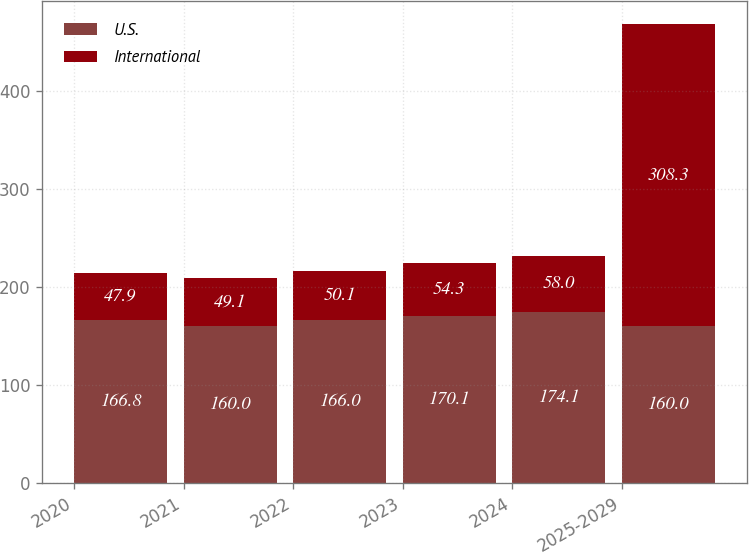Convert chart to OTSL. <chart><loc_0><loc_0><loc_500><loc_500><stacked_bar_chart><ecel><fcel>2020<fcel>2021<fcel>2022<fcel>2023<fcel>2024<fcel>2025-2029<nl><fcel>U.S.<fcel>166.8<fcel>160<fcel>166<fcel>170.1<fcel>174.1<fcel>160<nl><fcel>International<fcel>47.9<fcel>49.1<fcel>50.1<fcel>54.3<fcel>58<fcel>308.3<nl></chart> 